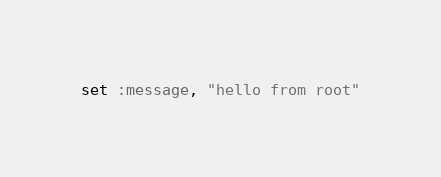<code> <loc_0><loc_0><loc_500><loc_500><_Ruby_>set :message, "hello from root"
</code> 